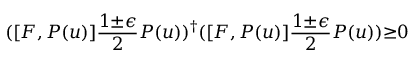Convert formula to latex. <formula><loc_0><loc_0><loc_500><loc_500>( [ F , P ( u ) ] \frac { 1 { \pm } { \epsilon } } { 2 } P ( u ) ) ^ { \dagger } ( [ F , P ( u ) ] \frac { 1 { \pm } { \epsilon } } { 2 } P ( u ) ) { \geq } 0</formula> 